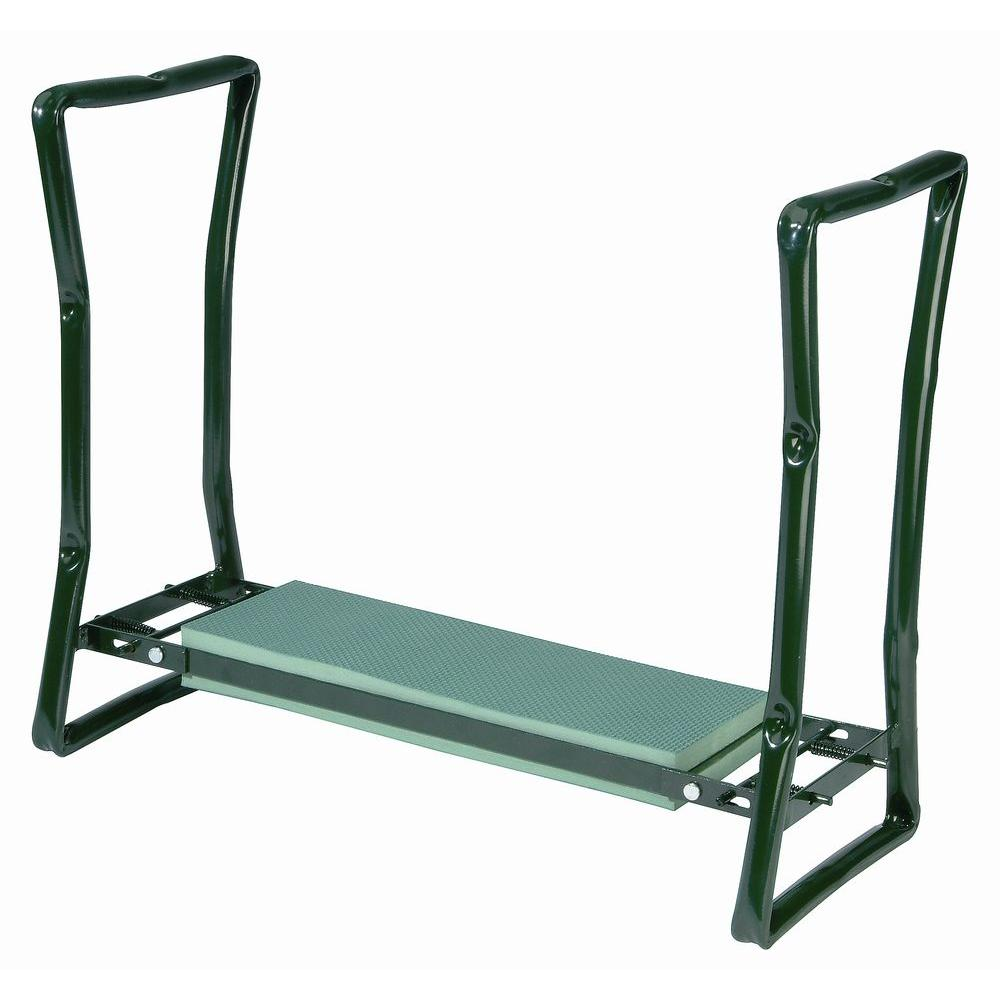How would the use of this squat stand vary among different types of athletes? This squat stand would be valuable across a range of athletic disciplines. Strength athletes, like powerlifters and weightlifters, would utilize it for basic squats and light bench presses, taking advantage of the stability and support for heavy lifts. Track and field athletes might use it for lighter, high-repetition workouts to build endurance and muscle tone. Moreover, it could also be beneficial for bodybuilders focusing on precise muscle isolation exercises to enhance both muscle mass and definition. Each type of athlete could adjust the stand to suit their specific workout intensity and safety needs. 